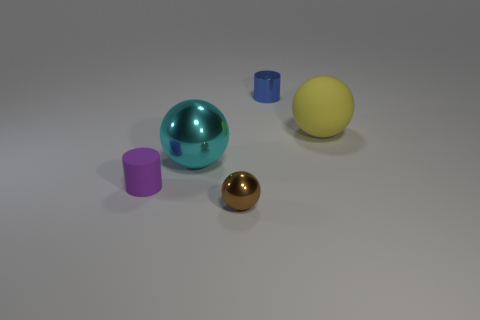What number of other things are the same color as the small rubber object?
Make the answer very short. 0. Does the yellow matte object have the same size as the cylinder to the right of the cyan metal ball?
Your answer should be very brief. No. There is a sphere that is to the right of the brown object; is its size the same as the tiny blue metallic cylinder?
Offer a very short reply. No. How many other objects are the same material as the small sphere?
Provide a succinct answer. 2. Are there an equal number of cylinders that are to the right of the brown shiny thing and metal things that are in front of the purple thing?
Make the answer very short. Yes. There is a tiny metal object that is in front of the large cyan sphere in front of the matte thing on the right side of the metal cylinder; what is its color?
Keep it short and to the point. Brown. There is a small shiny thing that is behind the tiny matte object; what shape is it?
Your answer should be compact. Cylinder. There is another object that is the same material as the yellow object; what is its shape?
Keep it short and to the point. Cylinder. Is there any other thing that is the same shape as the large cyan object?
Offer a terse response. Yes. There is a blue shiny object; what number of small blue metallic cylinders are behind it?
Offer a very short reply. 0. 